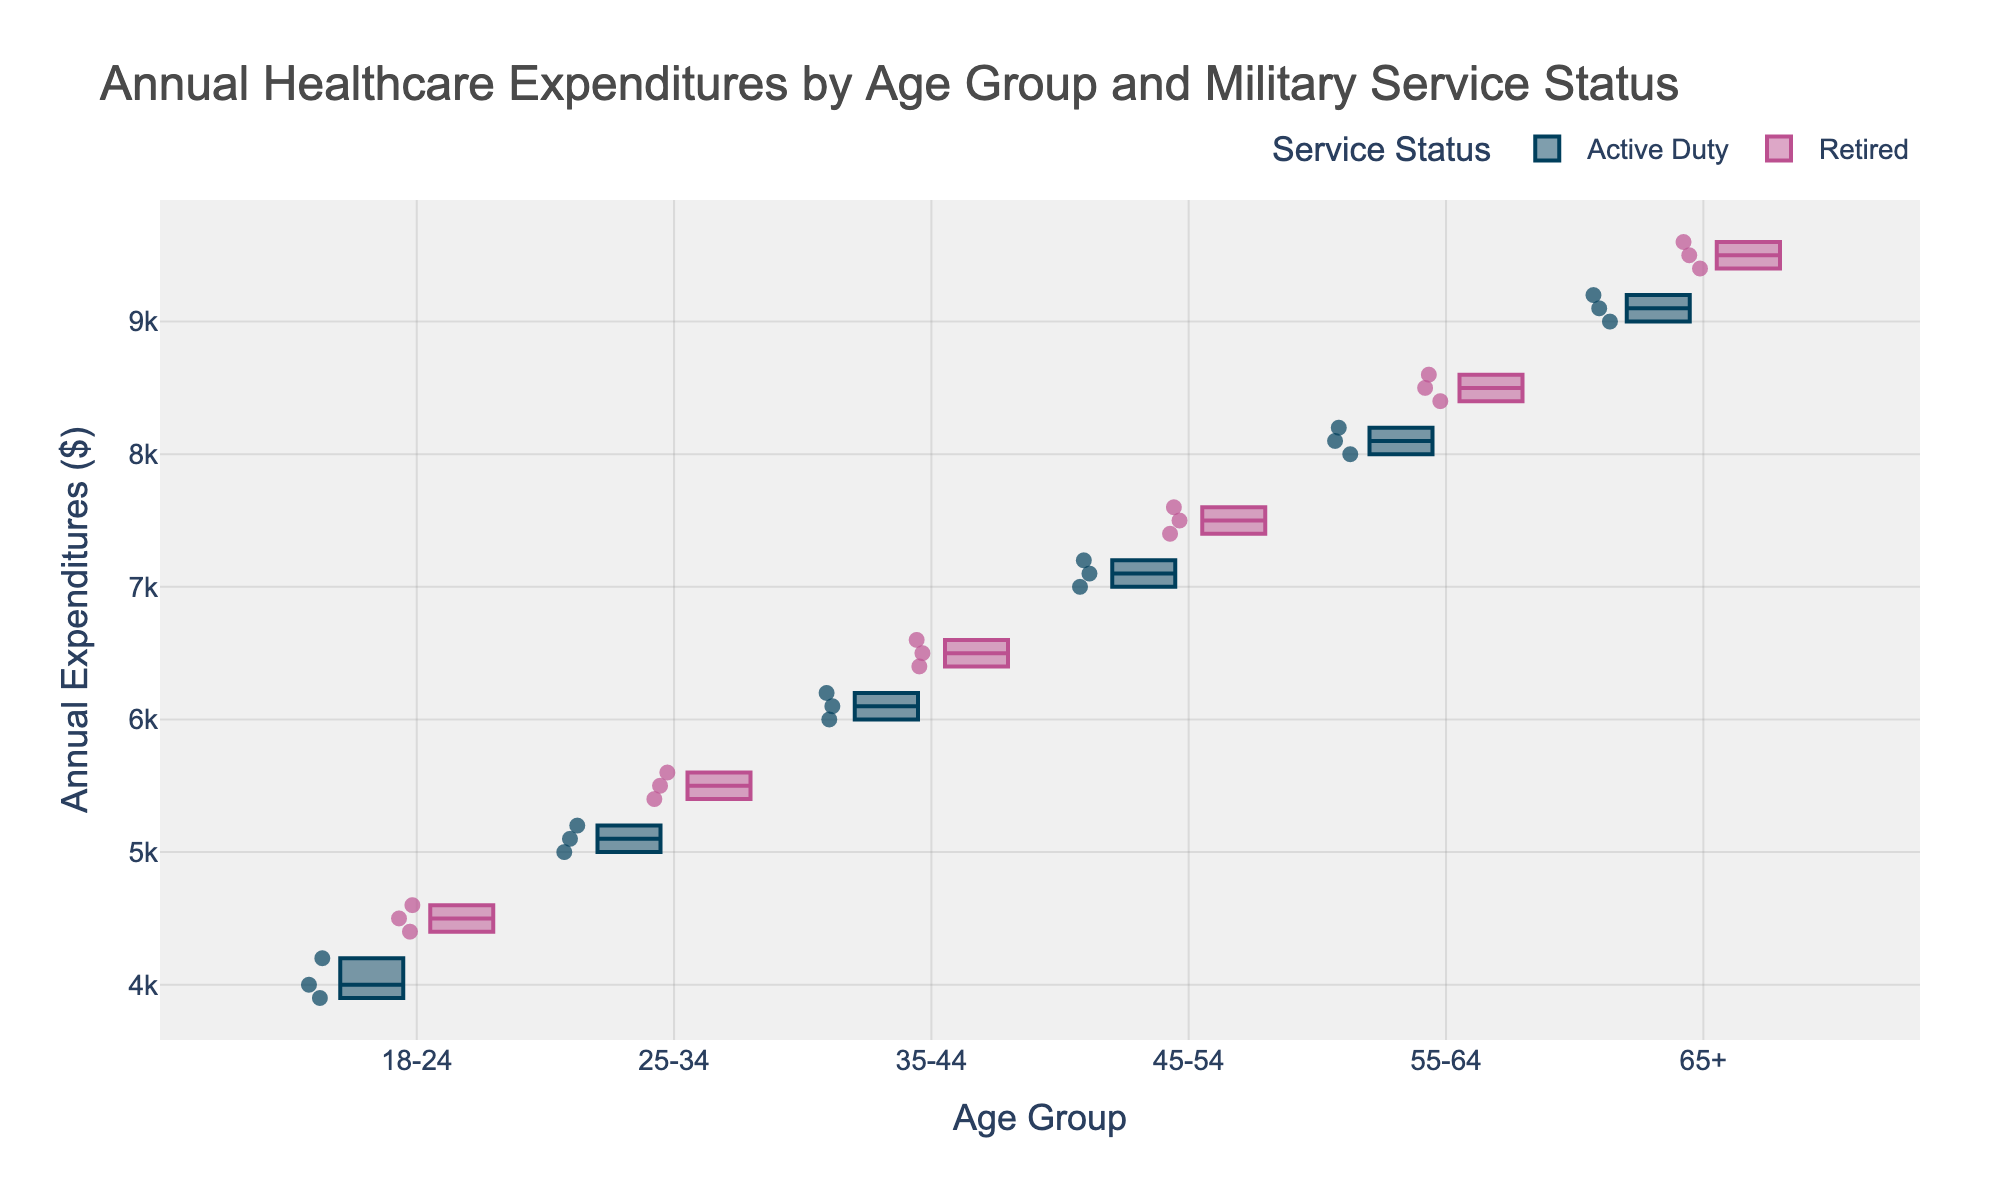What's the title of the figure? The title is displayed at the top of the figure and reads "Annual Healthcare Expenditures by Age Group and Military Service Status".
Answer: Annual Healthcare Expenditures by Age Group and Military Service Status What are the age groups represented in the figure? The x-axis of the figure lists the age groups, which include 18-24, 25-34, 35-44, 45-54, 55-64, and 65+.
Answer: 18-24, 25-34, 35-44, 45-54, 55-64, 65+ Which service status categories are included in the figure? There are two categories of service status represented by different colors in the figure: Active Duty and Retired.
Answer: Active Duty, Retired What is the color used to represent the Active Duty service status? The color used in the figure for the Active Duty service status is a dark blue.
Answer: Dark blue Between which age groups is there the highest median annual healthcare expenditure for Retired personnel? To determine this, look at the box plots for all age groups and identify which one has the highest middle line for the Retired service status boxes. The 65+ age group has the highest median.
Answer: 65+ For the age group 45-54, is the median healthcare expenditure higher for Active Duty or Retired personnel? Compare the middle lines of the box plots for the age group 45-54 between the Active Duty and Retired categories. The Retired category has a higher median expenditure.
Answer: Retired In which age group do Active Duty personnel have the lowest median annual healthcare expenditure? The lowest median expenditure for Active Duty personnel is identified by finding the box plot with the lowest middle line. This is in the 18-24 age group.
Answer: 18-24 How does the median healthcare expenditure for Active Duty personnel change with age? Observe the middle lines of the Active Duty box plots across age groups and note their trend. The medians increase consistently as age increases.
Answer: Increases For the 25-34 age group, what is the difference between the median expenditures of Retired and Active Duty personnel? Find the median values of the expenditures for both Retired and Active Duty in the 25-34 age group, and then calculate the difference. The difference is 5500 (Retired) - 5100 (Active Duty) = 400.
Answer: 400 Which service status has a greater overall variability in healthcare expenditures across all age groups? Variability in a box plot can be judged by the range of expenditures (distance between the smallest and largest points). By examining all box plots, it's clear that Retired personnel generally show greater variability.
Answer: Retired 